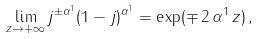Convert formula to latex. <formula><loc_0><loc_0><loc_500><loc_500>\lim _ { z \rightarrow + \infty } j ^ { \pm \alpha ^ { 1 } } ( 1 - j ) ^ { \alpha ^ { 1 } } = \exp ( \mp \, 2 \, \alpha ^ { 1 } \, z ) \, ,</formula> 